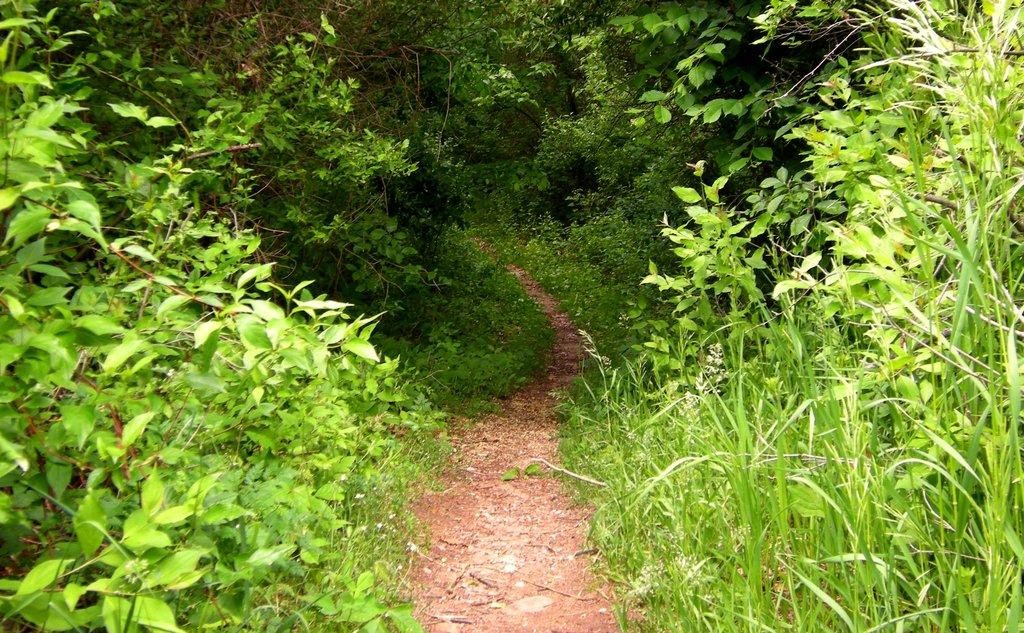What type of vegetation can be seen in the image? There are trees and plants in the image. Can you describe the path visible in the image? Yes, there is a path visible in the image. What type of music can be heard playing in the background of the image? There is no music present in the image, as it is a still image and does not have any audible elements. What type of dress is the plant wearing in the image? The plants in the image are not wearing any dress, as they are inanimate objects and do not have the ability to wear clothing. 